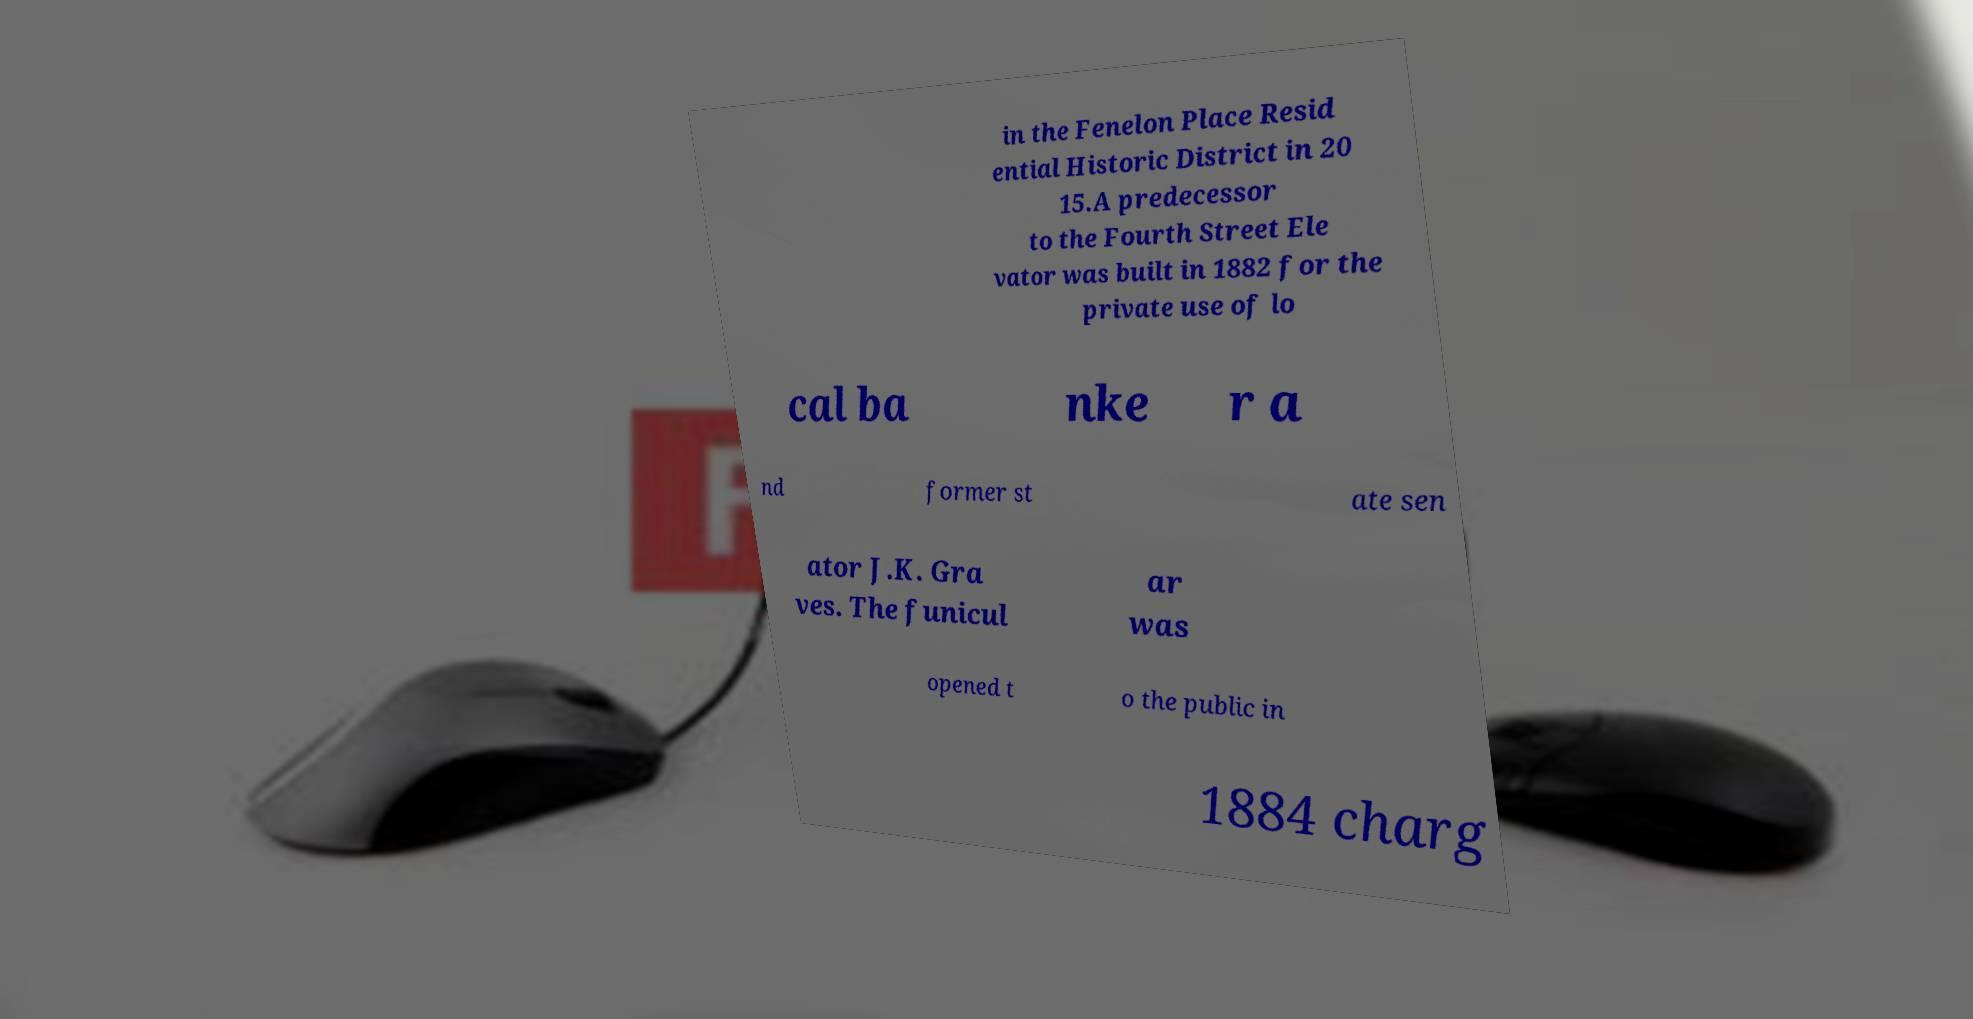Can you read and provide the text displayed in the image?This photo seems to have some interesting text. Can you extract and type it out for me? in the Fenelon Place Resid ential Historic District in 20 15.A predecessor to the Fourth Street Ele vator was built in 1882 for the private use of lo cal ba nke r a nd former st ate sen ator J.K. Gra ves. The funicul ar was opened t o the public in 1884 charg 